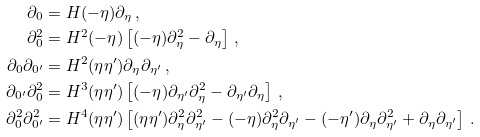Convert formula to latex. <formula><loc_0><loc_0><loc_500><loc_500>\partial _ { 0 } & = H ( - \eta ) \partial _ { \eta } \, , \\ \partial _ { 0 } ^ { 2 } & = H ^ { 2 } ( - \eta ) \left [ ( - \eta ) \partial _ { \eta } ^ { 2 } - \partial _ { \eta } \right ] \, , \\ \partial _ { 0 } \partial _ { 0 ^ { \prime } } & = H ^ { 2 } ( \eta \eta ^ { \prime } ) \partial _ { \eta } \partial _ { \eta ^ { \prime } } \, , \\ \partial _ { 0 ^ { \prime } } \partial _ { 0 } ^ { 2 } & = H ^ { 3 } ( \eta \eta ^ { \prime } ) \left [ ( - \eta ) \partial _ { \eta ^ { \prime } } \partial _ { \eta } ^ { 2 } - \partial _ { \eta ^ { \prime } } \partial _ { \eta } \right ] \, , \\ \partial _ { 0 } ^ { 2 } \partial _ { 0 ^ { \prime } } ^ { 2 } & = H ^ { 4 } ( \eta \eta ^ { \prime } ) \left [ ( \eta \eta ^ { \prime } ) \partial _ { \eta } ^ { 2 } \partial _ { \eta ^ { \prime } } ^ { 2 } - ( - \eta ) \partial _ { \eta } ^ { 2 } \partial _ { \eta ^ { \prime } } - ( - \eta ^ { \prime } ) \partial _ { \eta } \partial _ { \eta ^ { \prime } } ^ { 2 } + \partial _ { \eta } \partial _ { \eta ^ { \prime } } \right ] \, .</formula> 